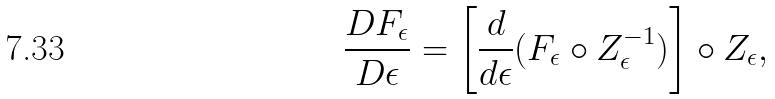Convert formula to latex. <formula><loc_0><loc_0><loc_500><loc_500>\frac { D F _ { \epsilon } } { D \epsilon } = \left [ \frac { d } { d \epsilon } ( F _ { \epsilon } \circ Z ^ { - 1 } _ { \epsilon } ) \right ] \circ Z _ { \epsilon } ,</formula> 